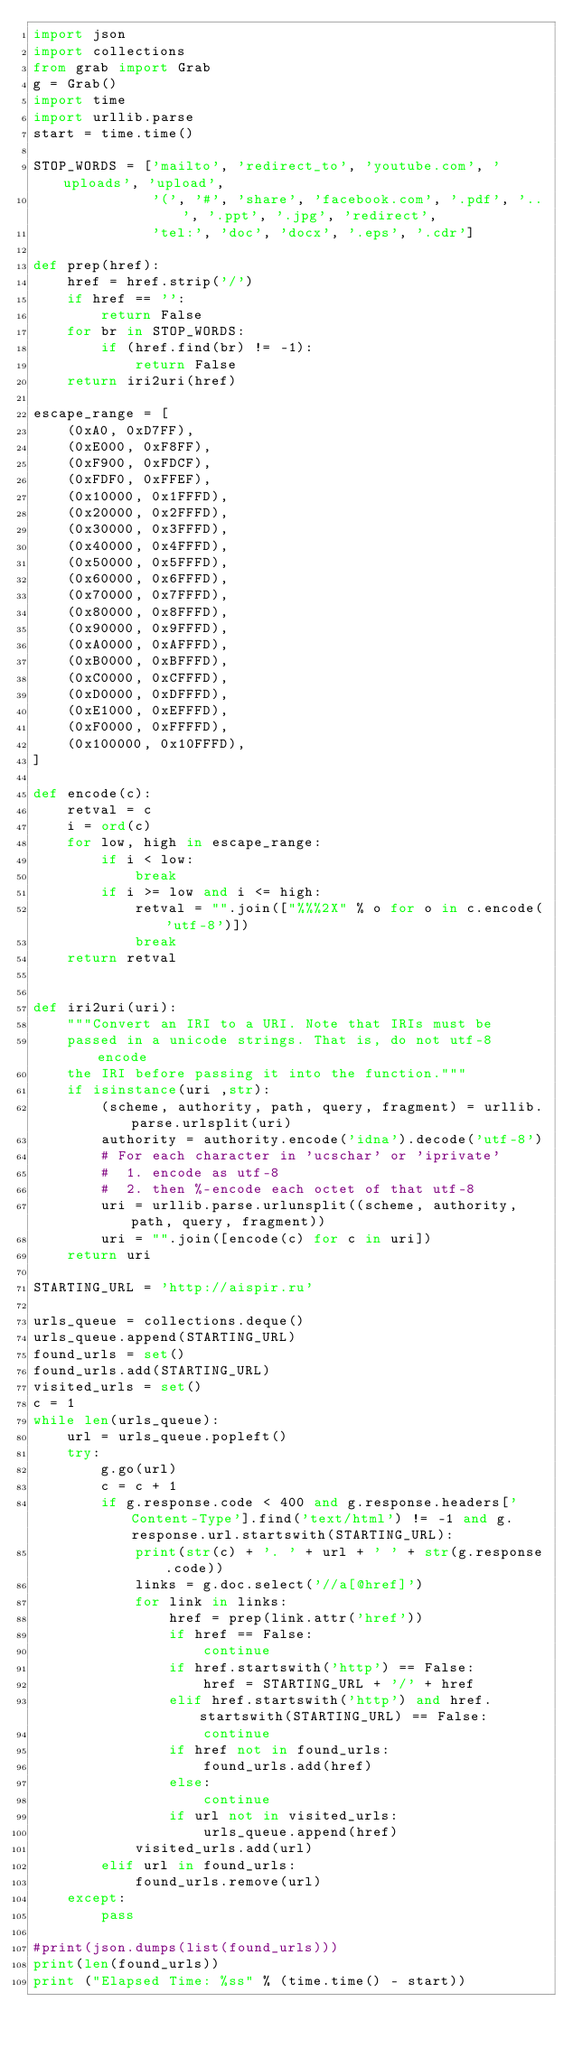<code> <loc_0><loc_0><loc_500><loc_500><_Python_>import json
import collections
from grab import Grab
g = Grab()
import time
import urllib.parse
start = time.time()

STOP_WORDS = ['mailto', 'redirect_to', 'youtube.com', 'uploads', 'upload',
              '(', '#', 'share', 'facebook.com', '.pdf', '..', '.ppt', '.jpg', 'redirect',
              'tel:', 'doc', 'docx', '.eps', '.cdr']

def prep(href):
    href = href.strip('/')
    if href == '':
        return False
    for br in STOP_WORDS:
        if (href.find(br) != -1):
            return False
    return iri2uri(href)

escape_range = [
    (0xA0, 0xD7FF),
    (0xE000, 0xF8FF),
    (0xF900, 0xFDCF),
    (0xFDF0, 0xFFEF),
    (0x10000, 0x1FFFD),
    (0x20000, 0x2FFFD),
    (0x30000, 0x3FFFD),
    (0x40000, 0x4FFFD),
    (0x50000, 0x5FFFD),
    (0x60000, 0x6FFFD),
    (0x70000, 0x7FFFD),
    (0x80000, 0x8FFFD),
    (0x90000, 0x9FFFD),
    (0xA0000, 0xAFFFD),
    (0xB0000, 0xBFFFD),
    (0xC0000, 0xCFFFD),
    (0xD0000, 0xDFFFD),
    (0xE1000, 0xEFFFD),
    (0xF0000, 0xFFFFD),
    (0x100000, 0x10FFFD),
]

def encode(c):
    retval = c
    i = ord(c)
    for low, high in escape_range:
        if i < low:
            break
        if i >= low and i <= high:
            retval = "".join(["%%%2X" % o for o in c.encode('utf-8')])
            break
    return retval


def iri2uri(uri):
    """Convert an IRI to a URI. Note that IRIs must be
    passed in a unicode strings. That is, do not utf-8 encode
    the IRI before passing it into the function."""
    if isinstance(uri ,str):
        (scheme, authority, path, query, fragment) = urllib.parse.urlsplit(uri)
        authority = authority.encode('idna').decode('utf-8')
        # For each character in 'ucschar' or 'iprivate'
        #  1. encode as utf-8
        #  2. then %-encode each octet of that utf-8
        uri = urllib.parse.urlunsplit((scheme, authority, path, query, fragment))
        uri = "".join([encode(c) for c in uri])
    return uri

STARTING_URL = 'http://aispir.ru'

urls_queue = collections.deque()
urls_queue.append(STARTING_URL)
found_urls = set()
found_urls.add(STARTING_URL)
visited_urls = set()
c = 1
while len(urls_queue):
    url = urls_queue.popleft()
    try:
        g.go(url)
        c = c + 1
        if g.response.code < 400 and g.response.headers['Content-Type'].find('text/html') != -1 and g.response.url.startswith(STARTING_URL):
            print(str(c) + '. ' + url + ' ' + str(g.response.code))
            links = g.doc.select('//a[@href]')
            for link in links:
                href = prep(link.attr('href'))
                if href == False:
                    continue
                if href.startswith('http') == False:
                    href = STARTING_URL + '/' + href
                elif href.startswith('http') and href.startswith(STARTING_URL) == False:
                    continue
                if href not in found_urls:
                    found_urls.add(href)
                else:
                    continue
                if url not in visited_urls:
                    urls_queue.append(href)
            visited_urls.add(url)
        elif url in found_urls:
            found_urls.remove(url)
    except:
        pass

#print(json.dumps(list(found_urls)))
print(len(found_urls))
print ("Elapsed Time: %ss" % (time.time() - start))</code> 